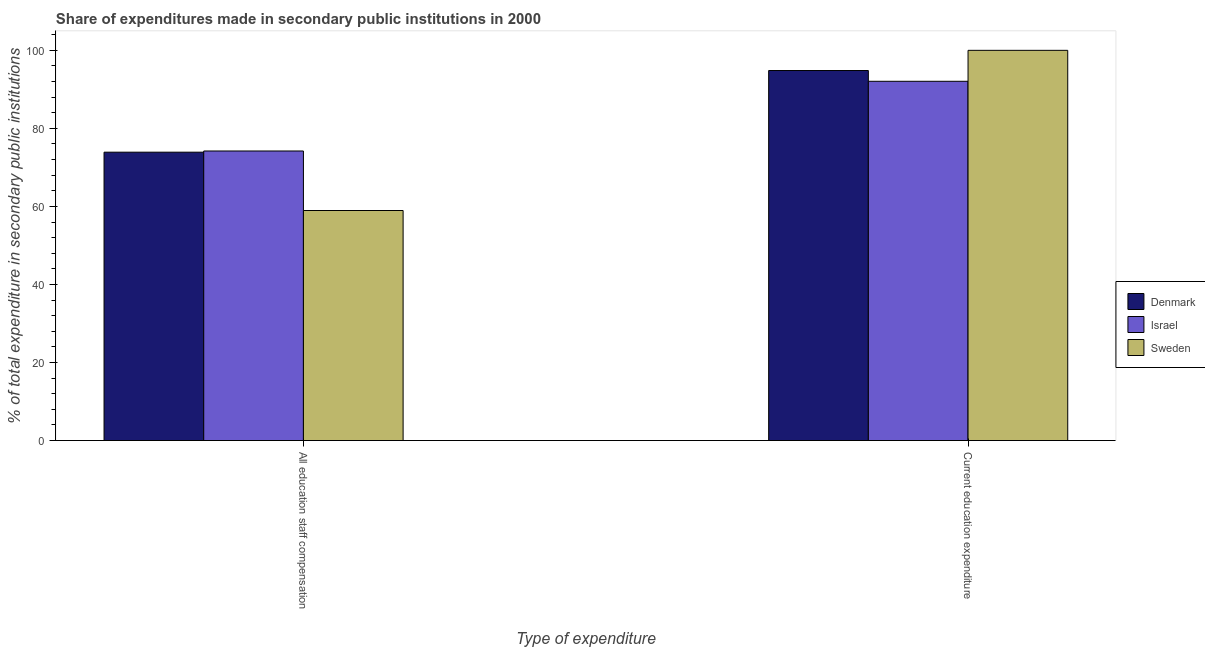How many groups of bars are there?
Offer a very short reply. 2. Are the number of bars on each tick of the X-axis equal?
Your response must be concise. Yes. How many bars are there on the 1st tick from the left?
Make the answer very short. 3. What is the label of the 1st group of bars from the left?
Make the answer very short. All education staff compensation. What is the expenditure in education in Israel?
Your response must be concise. 92.07. Across all countries, what is the maximum expenditure in staff compensation?
Make the answer very short. 74.21. Across all countries, what is the minimum expenditure in education?
Keep it short and to the point. 92.07. In which country was the expenditure in staff compensation maximum?
Give a very brief answer. Israel. In which country was the expenditure in staff compensation minimum?
Keep it short and to the point. Sweden. What is the total expenditure in education in the graph?
Offer a terse response. 286.9. What is the difference between the expenditure in education in Denmark and that in Sweden?
Your response must be concise. -5.17. What is the difference between the expenditure in education in Sweden and the expenditure in staff compensation in Denmark?
Ensure brevity in your answer.  26.1. What is the average expenditure in staff compensation per country?
Your answer should be compact. 69.02. What is the difference between the expenditure in staff compensation and expenditure in education in Denmark?
Keep it short and to the point. -20.93. In how many countries, is the expenditure in education greater than 60 %?
Make the answer very short. 3. What is the ratio of the expenditure in staff compensation in Israel to that in Sweden?
Your response must be concise. 1.26. Is the expenditure in staff compensation in Denmark less than that in Sweden?
Offer a very short reply. No. In how many countries, is the expenditure in staff compensation greater than the average expenditure in staff compensation taken over all countries?
Your answer should be compact. 2. What does the 1st bar from the right in Current education expenditure represents?
Keep it short and to the point. Sweden. How many bars are there?
Your response must be concise. 6. What is the difference between two consecutive major ticks on the Y-axis?
Your response must be concise. 20. Does the graph contain any zero values?
Provide a short and direct response. No. How many legend labels are there?
Offer a terse response. 3. How are the legend labels stacked?
Provide a short and direct response. Vertical. What is the title of the graph?
Your answer should be compact. Share of expenditures made in secondary public institutions in 2000. Does "Switzerland" appear as one of the legend labels in the graph?
Your answer should be very brief. No. What is the label or title of the X-axis?
Ensure brevity in your answer.  Type of expenditure. What is the label or title of the Y-axis?
Your answer should be compact. % of total expenditure in secondary public institutions. What is the % of total expenditure in secondary public institutions in Denmark in All education staff compensation?
Provide a short and direct response. 73.9. What is the % of total expenditure in secondary public institutions of Israel in All education staff compensation?
Provide a short and direct response. 74.21. What is the % of total expenditure in secondary public institutions in Sweden in All education staff compensation?
Offer a very short reply. 58.95. What is the % of total expenditure in secondary public institutions of Denmark in Current education expenditure?
Offer a very short reply. 94.83. What is the % of total expenditure in secondary public institutions of Israel in Current education expenditure?
Your response must be concise. 92.07. Across all Type of expenditure, what is the maximum % of total expenditure in secondary public institutions of Denmark?
Your response must be concise. 94.83. Across all Type of expenditure, what is the maximum % of total expenditure in secondary public institutions in Israel?
Make the answer very short. 92.07. Across all Type of expenditure, what is the maximum % of total expenditure in secondary public institutions in Sweden?
Offer a terse response. 100. Across all Type of expenditure, what is the minimum % of total expenditure in secondary public institutions in Denmark?
Your answer should be compact. 73.9. Across all Type of expenditure, what is the minimum % of total expenditure in secondary public institutions of Israel?
Keep it short and to the point. 74.21. Across all Type of expenditure, what is the minimum % of total expenditure in secondary public institutions in Sweden?
Offer a very short reply. 58.95. What is the total % of total expenditure in secondary public institutions in Denmark in the graph?
Ensure brevity in your answer.  168.73. What is the total % of total expenditure in secondary public institutions in Israel in the graph?
Provide a short and direct response. 166.28. What is the total % of total expenditure in secondary public institutions in Sweden in the graph?
Provide a short and direct response. 158.95. What is the difference between the % of total expenditure in secondary public institutions of Denmark in All education staff compensation and that in Current education expenditure?
Offer a very short reply. -20.93. What is the difference between the % of total expenditure in secondary public institutions of Israel in All education staff compensation and that in Current education expenditure?
Make the answer very short. -17.86. What is the difference between the % of total expenditure in secondary public institutions in Sweden in All education staff compensation and that in Current education expenditure?
Offer a terse response. -41.05. What is the difference between the % of total expenditure in secondary public institutions in Denmark in All education staff compensation and the % of total expenditure in secondary public institutions in Israel in Current education expenditure?
Give a very brief answer. -18.17. What is the difference between the % of total expenditure in secondary public institutions in Denmark in All education staff compensation and the % of total expenditure in secondary public institutions in Sweden in Current education expenditure?
Your answer should be very brief. -26.1. What is the difference between the % of total expenditure in secondary public institutions in Israel in All education staff compensation and the % of total expenditure in secondary public institutions in Sweden in Current education expenditure?
Give a very brief answer. -25.79. What is the average % of total expenditure in secondary public institutions in Denmark per Type of expenditure?
Make the answer very short. 84.37. What is the average % of total expenditure in secondary public institutions of Israel per Type of expenditure?
Your answer should be compact. 83.14. What is the average % of total expenditure in secondary public institutions in Sweden per Type of expenditure?
Give a very brief answer. 79.48. What is the difference between the % of total expenditure in secondary public institutions in Denmark and % of total expenditure in secondary public institutions in Israel in All education staff compensation?
Your response must be concise. -0.3. What is the difference between the % of total expenditure in secondary public institutions in Denmark and % of total expenditure in secondary public institutions in Sweden in All education staff compensation?
Keep it short and to the point. 14.95. What is the difference between the % of total expenditure in secondary public institutions in Israel and % of total expenditure in secondary public institutions in Sweden in All education staff compensation?
Provide a short and direct response. 15.25. What is the difference between the % of total expenditure in secondary public institutions of Denmark and % of total expenditure in secondary public institutions of Israel in Current education expenditure?
Provide a succinct answer. 2.76. What is the difference between the % of total expenditure in secondary public institutions of Denmark and % of total expenditure in secondary public institutions of Sweden in Current education expenditure?
Your answer should be compact. -5.17. What is the difference between the % of total expenditure in secondary public institutions of Israel and % of total expenditure in secondary public institutions of Sweden in Current education expenditure?
Offer a very short reply. -7.93. What is the ratio of the % of total expenditure in secondary public institutions in Denmark in All education staff compensation to that in Current education expenditure?
Provide a succinct answer. 0.78. What is the ratio of the % of total expenditure in secondary public institutions in Israel in All education staff compensation to that in Current education expenditure?
Provide a succinct answer. 0.81. What is the ratio of the % of total expenditure in secondary public institutions of Sweden in All education staff compensation to that in Current education expenditure?
Your answer should be compact. 0.59. What is the difference between the highest and the second highest % of total expenditure in secondary public institutions of Denmark?
Offer a terse response. 20.93. What is the difference between the highest and the second highest % of total expenditure in secondary public institutions of Israel?
Offer a very short reply. 17.86. What is the difference between the highest and the second highest % of total expenditure in secondary public institutions of Sweden?
Ensure brevity in your answer.  41.05. What is the difference between the highest and the lowest % of total expenditure in secondary public institutions in Denmark?
Your answer should be compact. 20.93. What is the difference between the highest and the lowest % of total expenditure in secondary public institutions in Israel?
Offer a terse response. 17.86. What is the difference between the highest and the lowest % of total expenditure in secondary public institutions of Sweden?
Your answer should be compact. 41.05. 